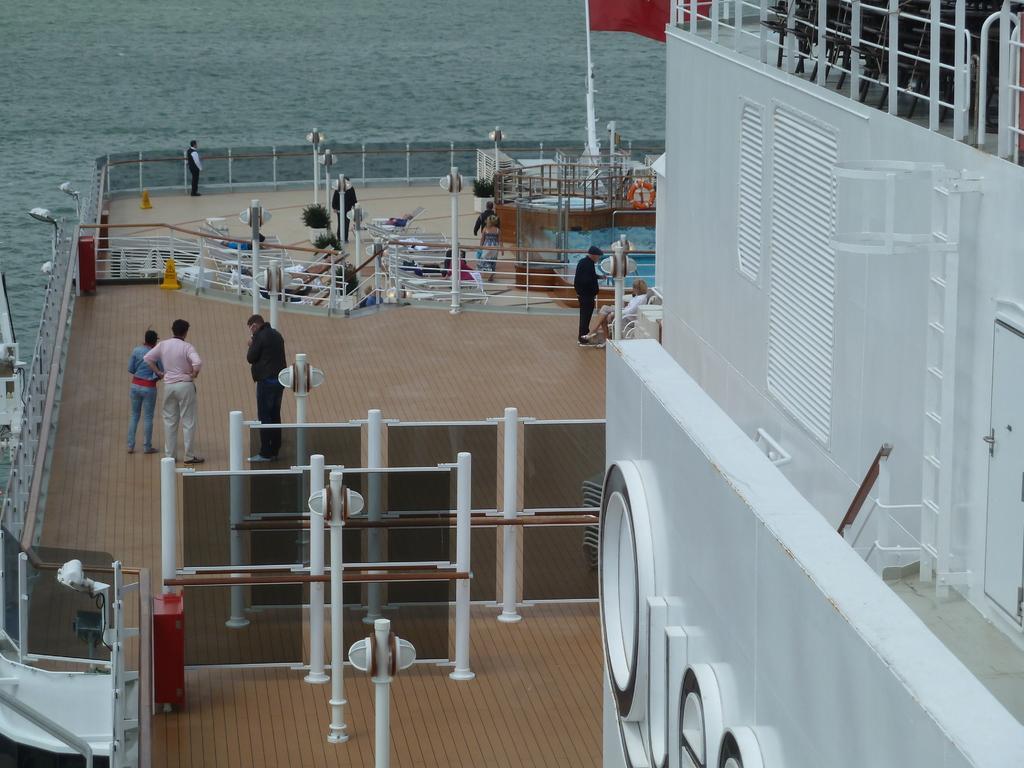Please provide a concise description of this image. There is a big ship on the water. Here we can see few persons standing on the floor,poles,light poles,flag,swimming pool and some other objects. On the right we can see a chairs at the fence,ladder,door and some other objects. In the background we can see water. 